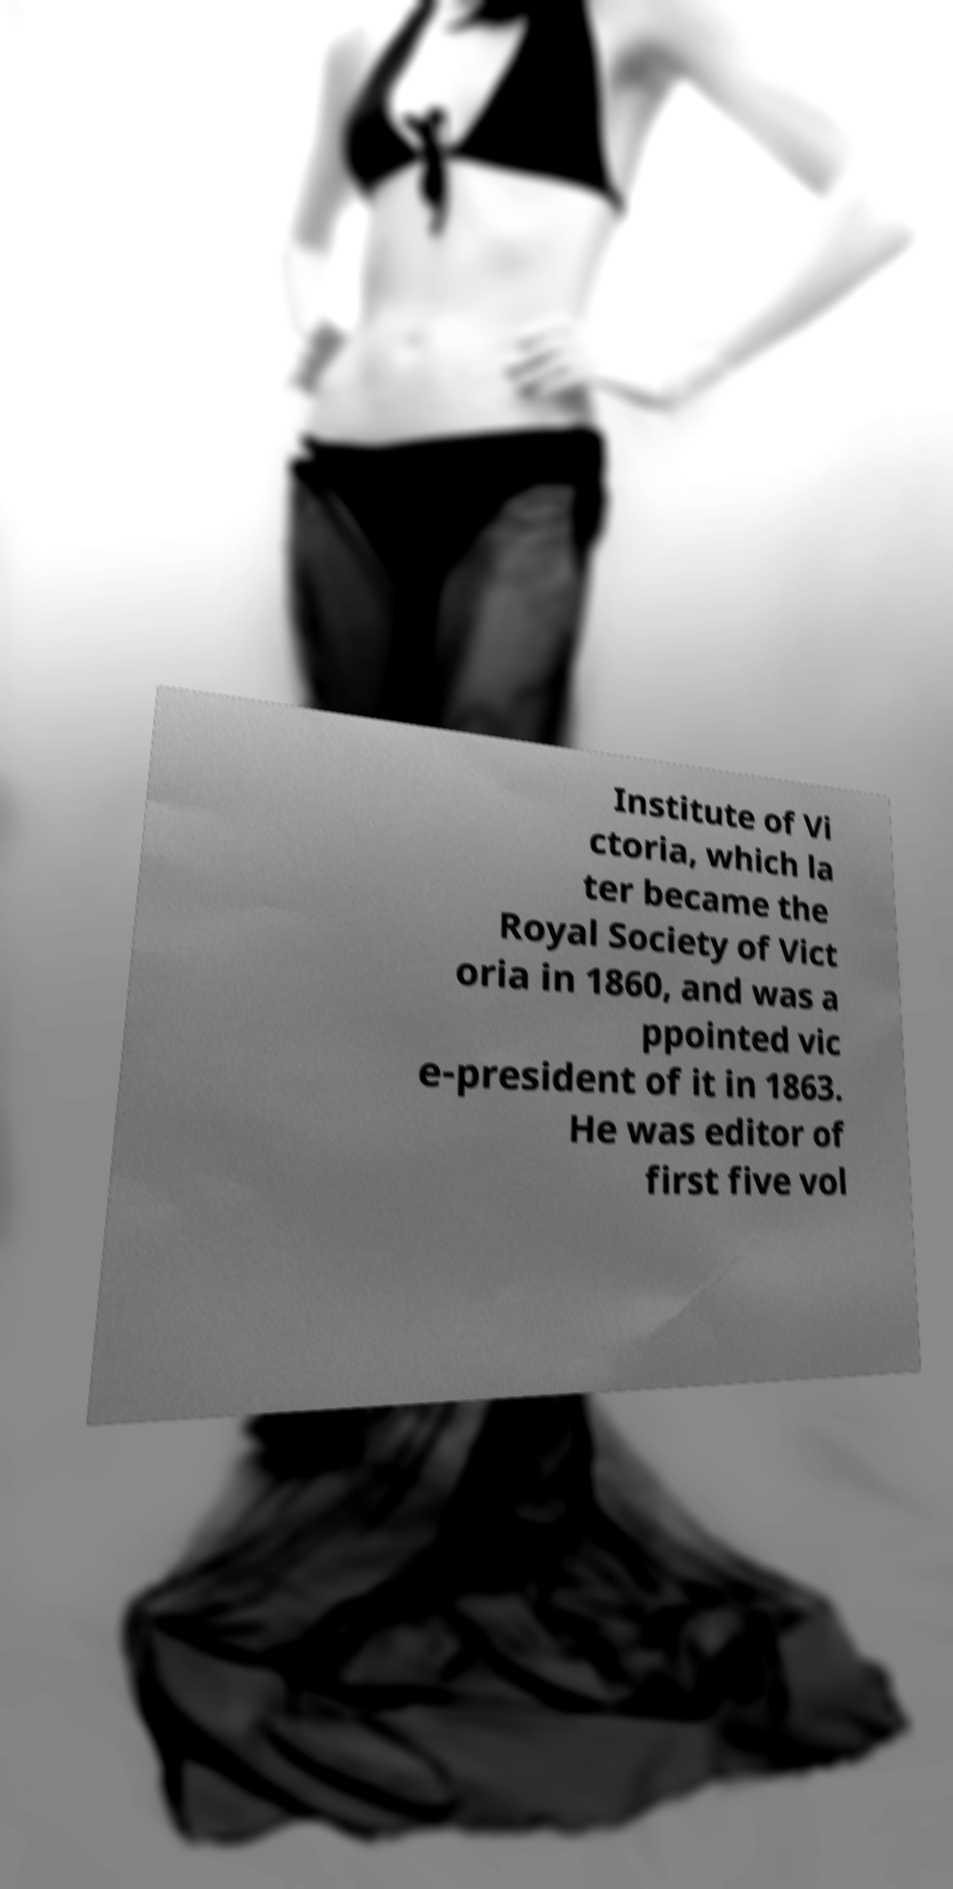Please read and relay the text visible in this image. What does it say? Institute of Vi ctoria, which la ter became the Royal Society of Vict oria in 1860, and was a ppointed vic e-president of it in 1863. He was editor of first five vol 